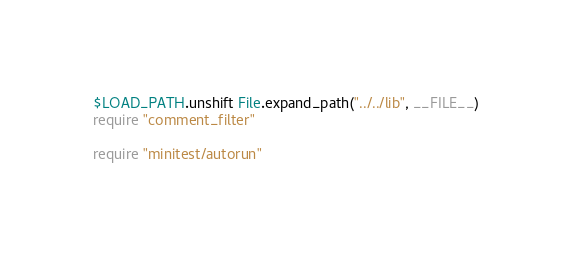<code> <loc_0><loc_0><loc_500><loc_500><_Ruby_>$LOAD_PATH.unshift File.expand_path("../../lib", __FILE__)
require "comment_filter"

require "minitest/autorun"
</code> 